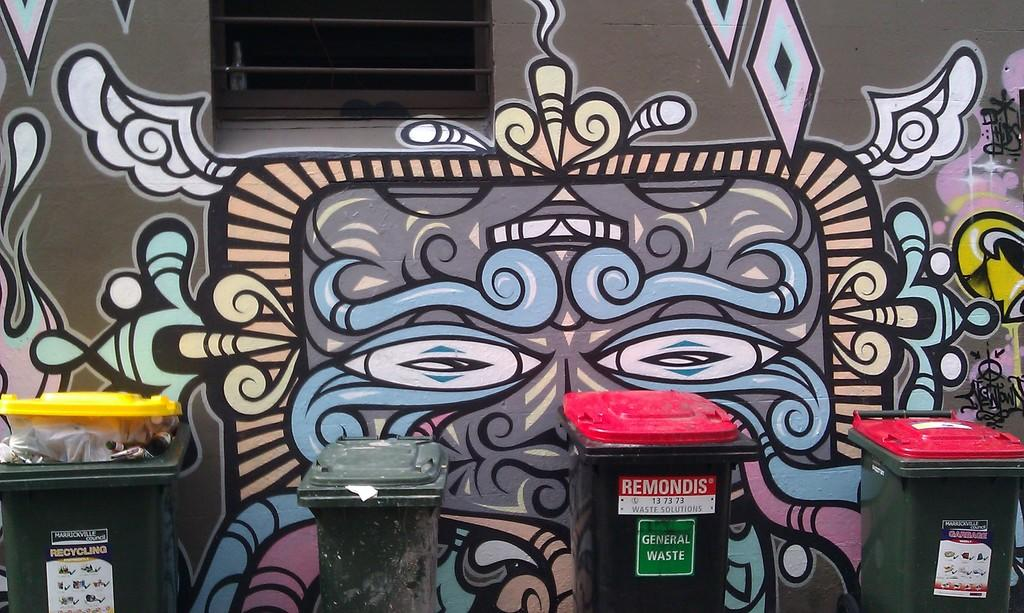<image>
Provide a brief description of the given image. Graffiti on the wall with a trasn can in front that says "REMONDIS". 